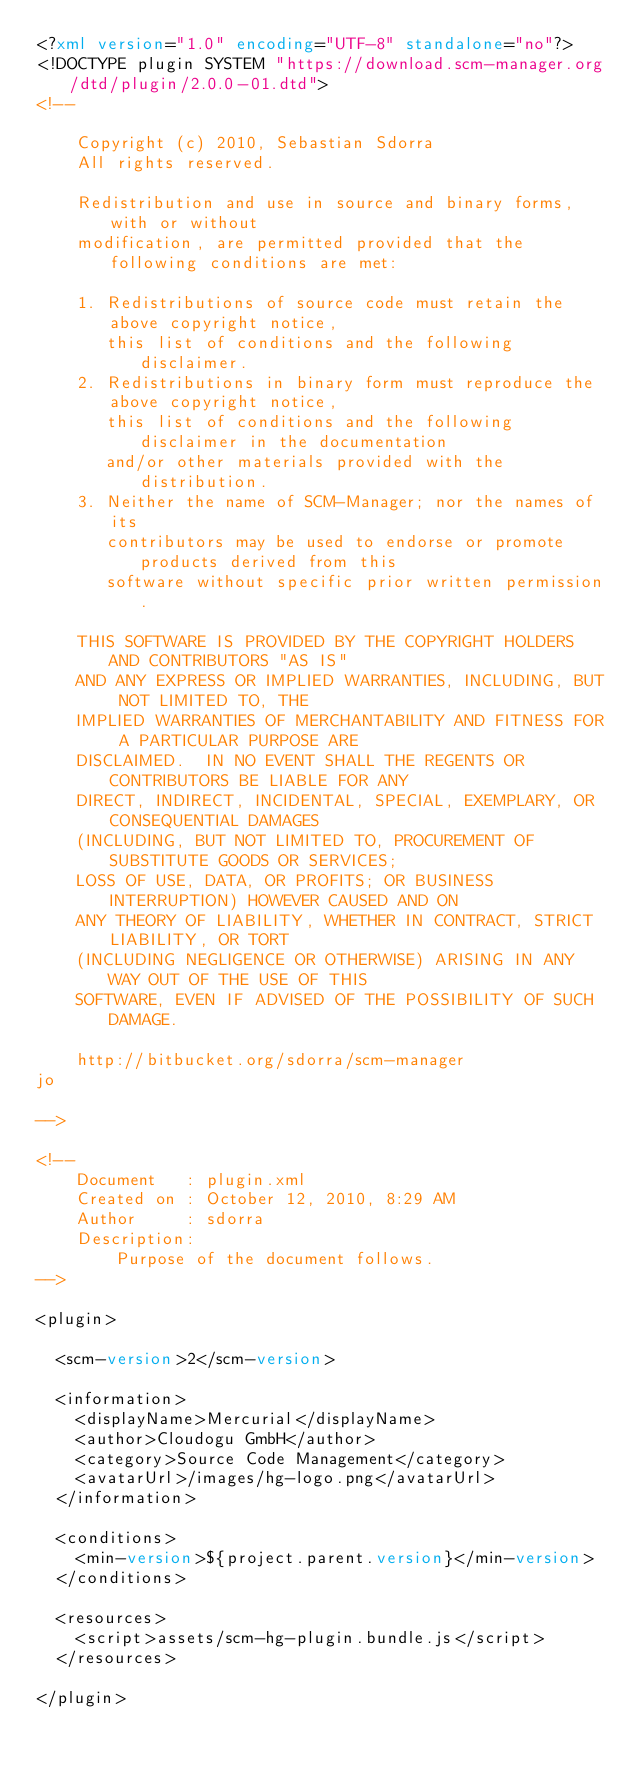Convert code to text. <code><loc_0><loc_0><loc_500><loc_500><_XML_><?xml version="1.0" encoding="UTF-8" standalone="no"?>
<!DOCTYPE plugin SYSTEM "https://download.scm-manager.org/dtd/plugin/2.0.0-01.dtd">
<!--

    Copyright (c) 2010, Sebastian Sdorra
    All rights reserved.

    Redistribution and use in source and binary forms, with or without
    modification, are permitted provided that the following conditions are met:

    1. Redistributions of source code must retain the above copyright notice,
       this list of conditions and the following disclaimer.
    2. Redistributions in binary form must reproduce the above copyright notice,
       this list of conditions and the following disclaimer in the documentation
       and/or other materials provided with the distribution.
    3. Neither the name of SCM-Manager; nor the names of its
       contributors may be used to endorse or promote products derived from this
       software without specific prior written permission.

    THIS SOFTWARE IS PROVIDED BY THE COPYRIGHT HOLDERS AND CONTRIBUTORS "AS IS"
    AND ANY EXPRESS OR IMPLIED WARRANTIES, INCLUDING, BUT NOT LIMITED TO, THE
    IMPLIED WARRANTIES OF MERCHANTABILITY AND FITNESS FOR A PARTICULAR PURPOSE ARE
    DISCLAIMED.  IN NO EVENT SHALL THE REGENTS OR CONTRIBUTORS BE LIABLE FOR ANY
    DIRECT, INDIRECT, INCIDENTAL, SPECIAL, EXEMPLARY, OR CONSEQUENTIAL DAMAGES
    (INCLUDING, BUT NOT LIMITED TO, PROCUREMENT OF SUBSTITUTE GOODS OR SERVICES;
    LOSS OF USE, DATA, OR PROFITS; OR BUSINESS INTERRUPTION) HOWEVER CAUSED AND ON
    ANY THEORY OF LIABILITY, WHETHER IN CONTRACT, STRICT LIABILITY, OR TORT
    (INCLUDING NEGLIGENCE OR OTHERWISE) ARISING IN ANY WAY OUT OF THE USE OF THIS
    SOFTWARE, EVEN IF ADVISED OF THE POSSIBILITY OF SUCH DAMAGE.

    http://bitbucket.org/sdorra/scm-manager
jo

-->

<!--
    Document   : plugin.xml
    Created on : October 12, 2010, 8:29 AM
    Author     : sdorra
    Description:
        Purpose of the document follows.
-->

<plugin>

  <scm-version>2</scm-version>

  <information>
    <displayName>Mercurial</displayName>
    <author>Cloudogu GmbH</author>
    <category>Source Code Management</category>
    <avatarUrl>/images/hg-logo.png</avatarUrl>
  </information>

  <conditions>
    <min-version>${project.parent.version}</min-version>
  </conditions>

  <resources>
    <script>assets/scm-hg-plugin.bundle.js</script>
  </resources>

</plugin>
</code> 